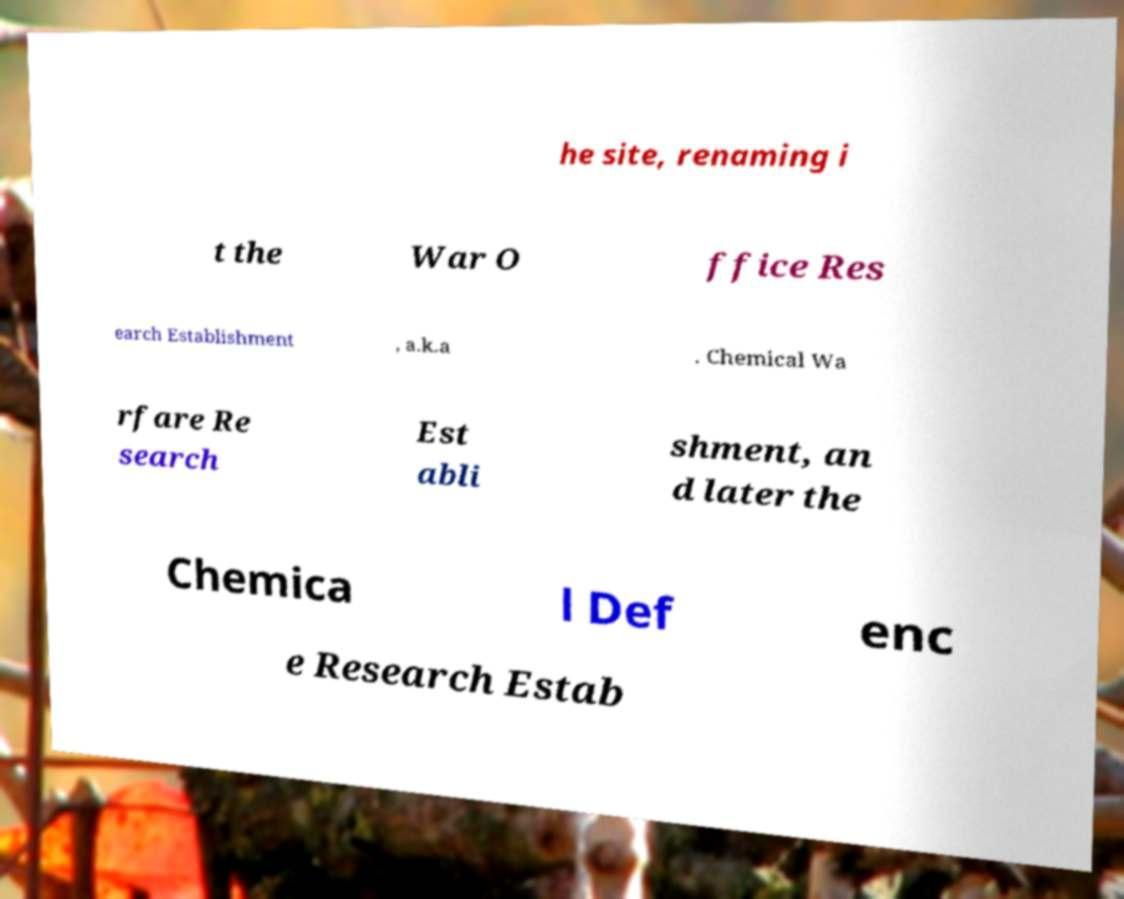Could you assist in decoding the text presented in this image and type it out clearly? he site, renaming i t the War O ffice Res earch Establishment , a.k.a . Chemical Wa rfare Re search Est abli shment, an d later the Chemica l Def enc e Research Estab 